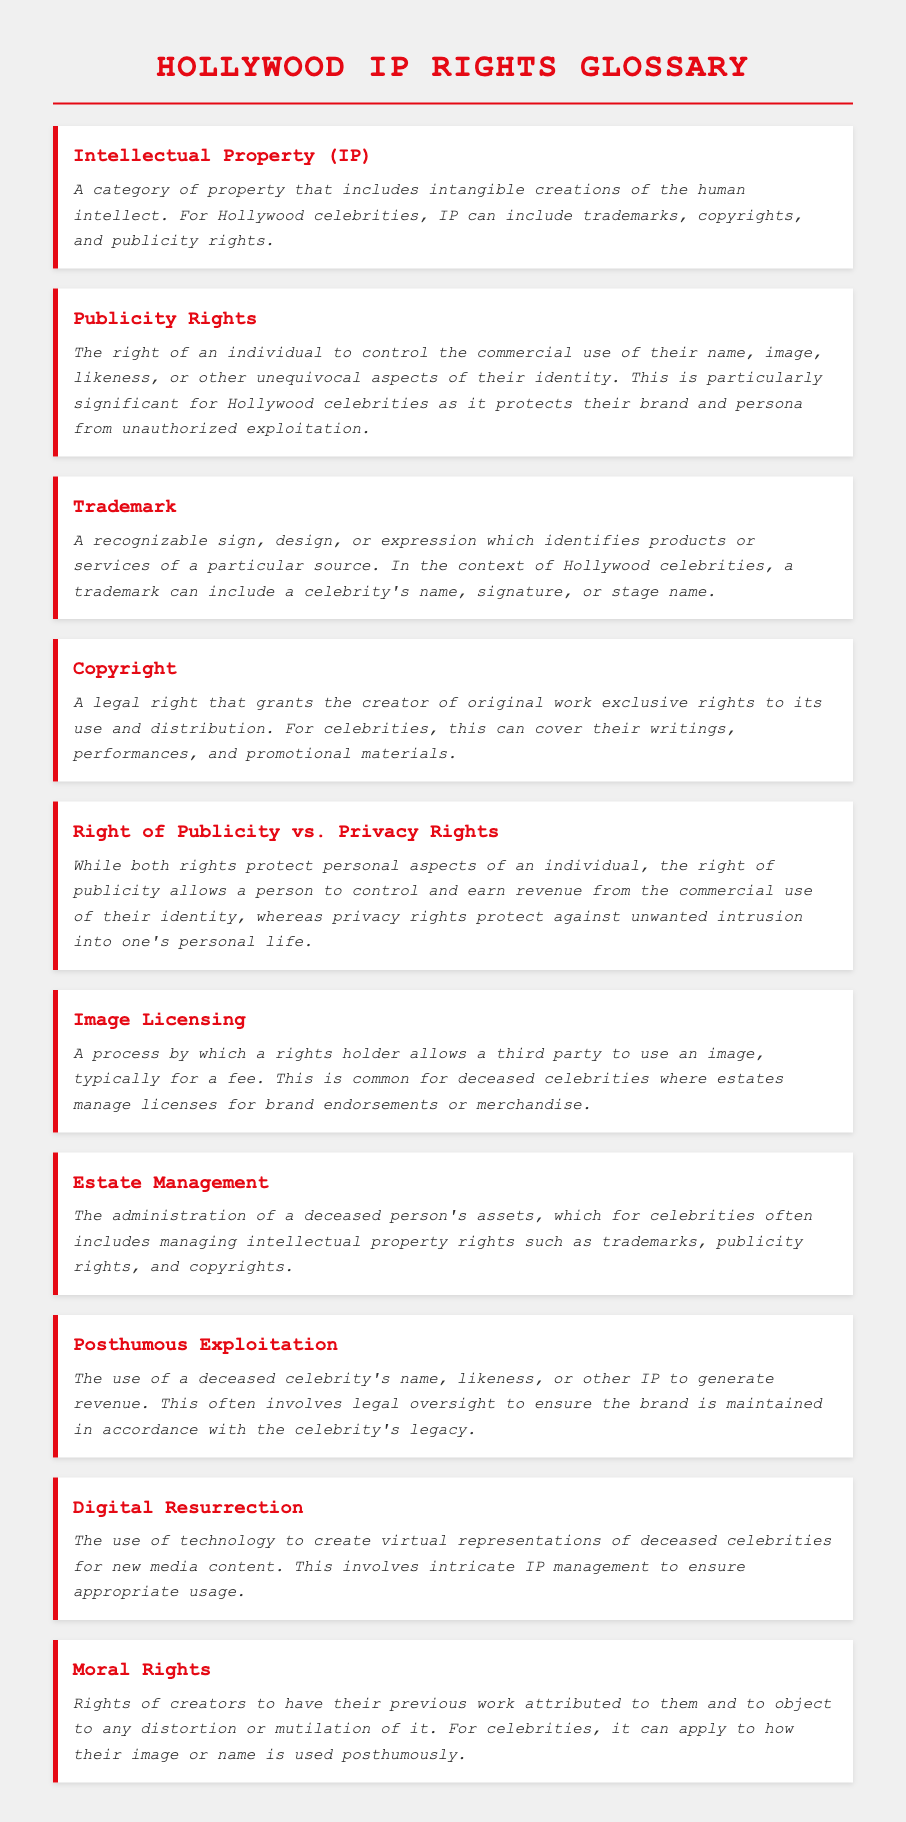what is the definition of Intellectual Property? The definition provides a category of property that includes intangible creations of the human intellect, specifically for Hollywood celebrities, it includes trademarks, copyrights, and publicity rights.
Answer: A category of property that includes intangible creations of the human intellect what are Publicity Rights? The definition explains the right of an individual to control the commercial use of their name, image, likeness, or aspects of their identity, specifically important for protecting the brand of Hollywood celebrities.
Answer: The right of an individual to control the commercial use of their name, image, likeness, or other aspects of their identity what does a Trademark include? The definition indicates that a trademark can include a recognizable sign, design, or expression that identifies products or services, specifically for celebrities it can include a name, signature, or stage name.
Answer: A celebrity's name, signature, or stage name what is the main difference between Right of Publicity and Privacy Rights? The definition lays out that while both protect personal aspects, the right of publicity allows for revenue control, whereas privacy rights protect against unwanted intrusion.
Answer: Revenue control vs. unwanted intrusion what is Image Licensing? The definition describes it as a process by which a rights holder allows a third party to use an image, typically for a fee, which is common for deceased celebrities.
Answer: A process allowing a third party to use an image, typically for a fee what is meant by Posthumous Exploitation? The definition explains this as the use of a deceased celebrity's name, likeness, or other IP to generate revenue, involving legal oversight to maintain the brand.
Answer: The use of a deceased celebrity's name or likeness to generate revenue how are Moral Rights defined for celebrities? The definition states that moral rights are about creators having their work attributed and objecting to any distortion, specifically applicable to posthumous usage of their image or name.
Answer: Rights of creators to have their previous work attributed to them how does Digital Resurrection relate to IP management? The definition suggests that it involves creating virtual representations of deceased celebrities, which calls for intricate IP management to ensure appropriate usage.
Answer: Creating virtual representations of deceased celebrities involves intricate IP management 